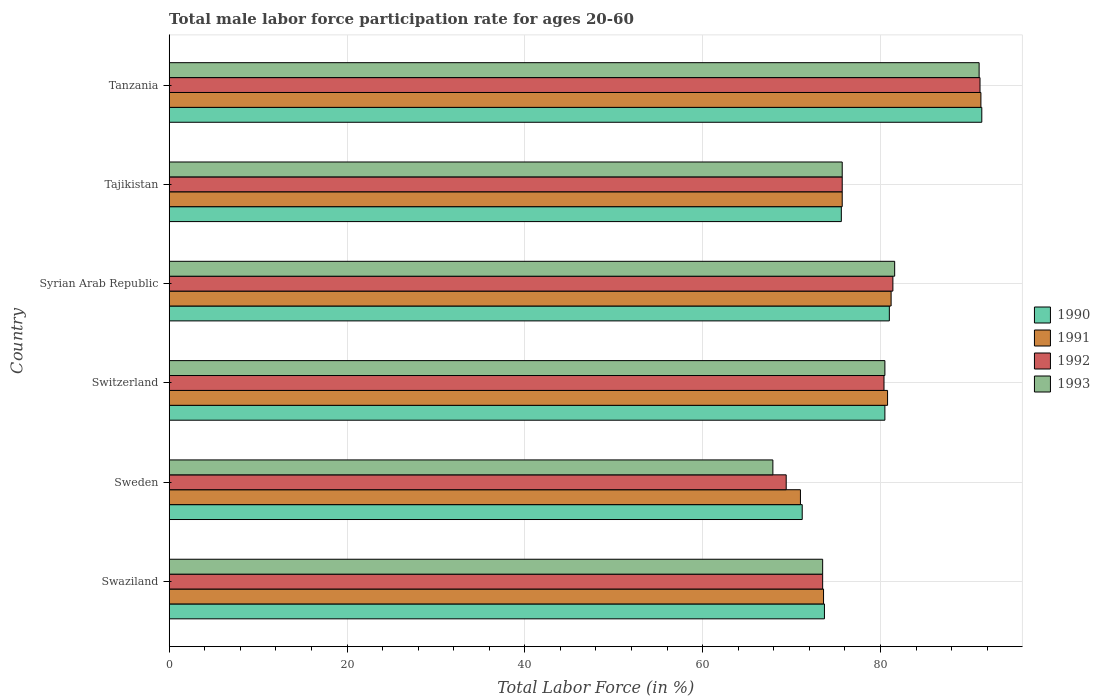How many different coloured bars are there?
Make the answer very short. 4. What is the label of the 3rd group of bars from the top?
Your answer should be compact. Syrian Arab Republic. In how many cases, is the number of bars for a given country not equal to the number of legend labels?
Give a very brief answer. 0. What is the male labor force participation rate in 1990 in Tanzania?
Keep it short and to the point. 91.4. Across all countries, what is the maximum male labor force participation rate in 1993?
Your answer should be compact. 91.1. Across all countries, what is the minimum male labor force participation rate in 1992?
Your answer should be compact. 69.4. In which country was the male labor force participation rate in 1993 maximum?
Your answer should be very brief. Tanzania. What is the total male labor force participation rate in 1991 in the graph?
Provide a succinct answer. 473.6. What is the difference between the male labor force participation rate in 1993 in Sweden and that in Switzerland?
Give a very brief answer. -12.6. What is the difference between the male labor force participation rate in 1993 in Syrian Arab Republic and the male labor force participation rate in 1990 in Sweden?
Ensure brevity in your answer.  10.4. What is the average male labor force participation rate in 1993 per country?
Offer a very short reply. 78.38. What is the difference between the male labor force participation rate in 1993 and male labor force participation rate in 1990 in Tajikistan?
Ensure brevity in your answer.  0.1. In how many countries, is the male labor force participation rate in 1992 greater than 12 %?
Your answer should be compact. 6. What is the ratio of the male labor force participation rate in 1991 in Switzerland to that in Syrian Arab Republic?
Offer a very short reply. 1. What is the difference between the highest and the second highest male labor force participation rate in 1993?
Your answer should be compact. 9.5. What is the difference between the highest and the lowest male labor force participation rate in 1991?
Provide a short and direct response. 20.3. Is the sum of the male labor force participation rate in 1993 in Swaziland and Tanzania greater than the maximum male labor force participation rate in 1990 across all countries?
Keep it short and to the point. Yes. What does the 1st bar from the top in Syrian Arab Republic represents?
Give a very brief answer. 1993. What does the 3rd bar from the bottom in Swaziland represents?
Provide a succinct answer. 1992. How many bars are there?
Make the answer very short. 24. Are all the bars in the graph horizontal?
Offer a very short reply. Yes. How many countries are there in the graph?
Ensure brevity in your answer.  6. Does the graph contain grids?
Provide a succinct answer. Yes. Where does the legend appear in the graph?
Make the answer very short. Center right. How many legend labels are there?
Your answer should be compact. 4. What is the title of the graph?
Make the answer very short. Total male labor force participation rate for ages 20-60. Does "1981" appear as one of the legend labels in the graph?
Offer a very short reply. No. What is the Total Labor Force (in %) of 1990 in Swaziland?
Make the answer very short. 73.7. What is the Total Labor Force (in %) of 1991 in Swaziland?
Give a very brief answer. 73.6. What is the Total Labor Force (in %) in 1992 in Swaziland?
Your response must be concise. 73.5. What is the Total Labor Force (in %) in 1993 in Swaziland?
Your answer should be very brief. 73.5. What is the Total Labor Force (in %) of 1990 in Sweden?
Give a very brief answer. 71.2. What is the Total Labor Force (in %) in 1991 in Sweden?
Your answer should be compact. 71. What is the Total Labor Force (in %) in 1992 in Sweden?
Provide a succinct answer. 69.4. What is the Total Labor Force (in %) in 1993 in Sweden?
Offer a very short reply. 67.9. What is the Total Labor Force (in %) of 1990 in Switzerland?
Keep it short and to the point. 80.5. What is the Total Labor Force (in %) in 1991 in Switzerland?
Provide a succinct answer. 80.8. What is the Total Labor Force (in %) in 1992 in Switzerland?
Your response must be concise. 80.4. What is the Total Labor Force (in %) of 1993 in Switzerland?
Give a very brief answer. 80.5. What is the Total Labor Force (in %) in 1990 in Syrian Arab Republic?
Your answer should be very brief. 81. What is the Total Labor Force (in %) of 1991 in Syrian Arab Republic?
Ensure brevity in your answer.  81.2. What is the Total Labor Force (in %) in 1992 in Syrian Arab Republic?
Provide a short and direct response. 81.4. What is the Total Labor Force (in %) of 1993 in Syrian Arab Republic?
Give a very brief answer. 81.6. What is the Total Labor Force (in %) in 1990 in Tajikistan?
Offer a very short reply. 75.6. What is the Total Labor Force (in %) of 1991 in Tajikistan?
Your response must be concise. 75.7. What is the Total Labor Force (in %) in 1992 in Tajikistan?
Provide a short and direct response. 75.7. What is the Total Labor Force (in %) of 1993 in Tajikistan?
Provide a short and direct response. 75.7. What is the Total Labor Force (in %) in 1990 in Tanzania?
Make the answer very short. 91.4. What is the Total Labor Force (in %) in 1991 in Tanzania?
Provide a succinct answer. 91.3. What is the Total Labor Force (in %) in 1992 in Tanzania?
Make the answer very short. 91.2. What is the Total Labor Force (in %) of 1993 in Tanzania?
Offer a terse response. 91.1. Across all countries, what is the maximum Total Labor Force (in %) in 1990?
Offer a terse response. 91.4. Across all countries, what is the maximum Total Labor Force (in %) of 1991?
Your answer should be very brief. 91.3. Across all countries, what is the maximum Total Labor Force (in %) of 1992?
Provide a short and direct response. 91.2. Across all countries, what is the maximum Total Labor Force (in %) of 1993?
Offer a very short reply. 91.1. Across all countries, what is the minimum Total Labor Force (in %) in 1990?
Keep it short and to the point. 71.2. Across all countries, what is the minimum Total Labor Force (in %) of 1991?
Your answer should be very brief. 71. Across all countries, what is the minimum Total Labor Force (in %) in 1992?
Your answer should be very brief. 69.4. Across all countries, what is the minimum Total Labor Force (in %) in 1993?
Make the answer very short. 67.9. What is the total Total Labor Force (in %) in 1990 in the graph?
Give a very brief answer. 473.4. What is the total Total Labor Force (in %) in 1991 in the graph?
Provide a short and direct response. 473.6. What is the total Total Labor Force (in %) of 1992 in the graph?
Keep it short and to the point. 471.6. What is the total Total Labor Force (in %) in 1993 in the graph?
Your response must be concise. 470.3. What is the difference between the Total Labor Force (in %) in 1992 in Swaziland and that in Sweden?
Offer a very short reply. 4.1. What is the difference between the Total Labor Force (in %) in 1993 in Swaziland and that in Sweden?
Your answer should be compact. 5.6. What is the difference between the Total Labor Force (in %) of 1991 in Swaziland and that in Switzerland?
Your answer should be compact. -7.2. What is the difference between the Total Labor Force (in %) in 1992 in Swaziland and that in Switzerland?
Your answer should be very brief. -6.9. What is the difference between the Total Labor Force (in %) in 1991 in Swaziland and that in Syrian Arab Republic?
Offer a very short reply. -7.6. What is the difference between the Total Labor Force (in %) in 1991 in Swaziland and that in Tajikistan?
Your answer should be very brief. -2.1. What is the difference between the Total Labor Force (in %) in 1990 in Swaziland and that in Tanzania?
Your answer should be very brief. -17.7. What is the difference between the Total Labor Force (in %) in 1991 in Swaziland and that in Tanzania?
Your response must be concise. -17.7. What is the difference between the Total Labor Force (in %) in 1992 in Swaziland and that in Tanzania?
Keep it short and to the point. -17.7. What is the difference between the Total Labor Force (in %) in 1993 in Swaziland and that in Tanzania?
Offer a very short reply. -17.6. What is the difference between the Total Labor Force (in %) in 1990 in Sweden and that in Switzerland?
Give a very brief answer. -9.3. What is the difference between the Total Labor Force (in %) in 1993 in Sweden and that in Switzerland?
Provide a short and direct response. -12.6. What is the difference between the Total Labor Force (in %) in 1991 in Sweden and that in Syrian Arab Republic?
Offer a very short reply. -10.2. What is the difference between the Total Labor Force (in %) in 1993 in Sweden and that in Syrian Arab Republic?
Give a very brief answer. -13.7. What is the difference between the Total Labor Force (in %) of 1991 in Sweden and that in Tajikistan?
Offer a terse response. -4.7. What is the difference between the Total Labor Force (in %) of 1990 in Sweden and that in Tanzania?
Keep it short and to the point. -20.2. What is the difference between the Total Labor Force (in %) of 1991 in Sweden and that in Tanzania?
Your answer should be compact. -20.3. What is the difference between the Total Labor Force (in %) of 1992 in Sweden and that in Tanzania?
Provide a short and direct response. -21.8. What is the difference between the Total Labor Force (in %) of 1993 in Sweden and that in Tanzania?
Keep it short and to the point. -23.2. What is the difference between the Total Labor Force (in %) of 1990 in Switzerland and that in Syrian Arab Republic?
Offer a very short reply. -0.5. What is the difference between the Total Labor Force (in %) in 1991 in Switzerland and that in Syrian Arab Republic?
Offer a very short reply. -0.4. What is the difference between the Total Labor Force (in %) of 1992 in Switzerland and that in Syrian Arab Republic?
Offer a terse response. -1. What is the difference between the Total Labor Force (in %) of 1993 in Switzerland and that in Syrian Arab Republic?
Give a very brief answer. -1.1. What is the difference between the Total Labor Force (in %) of 1991 in Switzerland and that in Tajikistan?
Provide a succinct answer. 5.1. What is the difference between the Total Labor Force (in %) in 1993 in Switzerland and that in Tanzania?
Make the answer very short. -10.6. What is the difference between the Total Labor Force (in %) in 1990 in Syrian Arab Republic and that in Tajikistan?
Provide a short and direct response. 5.4. What is the difference between the Total Labor Force (in %) in 1992 in Syrian Arab Republic and that in Tajikistan?
Provide a short and direct response. 5.7. What is the difference between the Total Labor Force (in %) in 1990 in Syrian Arab Republic and that in Tanzania?
Your answer should be compact. -10.4. What is the difference between the Total Labor Force (in %) of 1992 in Syrian Arab Republic and that in Tanzania?
Make the answer very short. -9.8. What is the difference between the Total Labor Force (in %) in 1990 in Tajikistan and that in Tanzania?
Ensure brevity in your answer.  -15.8. What is the difference between the Total Labor Force (in %) in 1991 in Tajikistan and that in Tanzania?
Provide a short and direct response. -15.6. What is the difference between the Total Labor Force (in %) in 1992 in Tajikistan and that in Tanzania?
Ensure brevity in your answer.  -15.5. What is the difference between the Total Labor Force (in %) of 1993 in Tajikistan and that in Tanzania?
Your answer should be compact. -15.4. What is the difference between the Total Labor Force (in %) of 1990 in Swaziland and the Total Labor Force (in %) of 1992 in Sweden?
Your answer should be very brief. 4.3. What is the difference between the Total Labor Force (in %) in 1990 in Swaziland and the Total Labor Force (in %) in 1993 in Sweden?
Give a very brief answer. 5.8. What is the difference between the Total Labor Force (in %) of 1991 in Swaziland and the Total Labor Force (in %) of 1992 in Sweden?
Make the answer very short. 4.2. What is the difference between the Total Labor Force (in %) of 1992 in Swaziland and the Total Labor Force (in %) of 1993 in Sweden?
Make the answer very short. 5.6. What is the difference between the Total Labor Force (in %) of 1990 in Swaziland and the Total Labor Force (in %) of 1991 in Switzerland?
Provide a succinct answer. -7.1. What is the difference between the Total Labor Force (in %) in 1991 in Swaziland and the Total Labor Force (in %) in 1993 in Switzerland?
Provide a short and direct response. -6.9. What is the difference between the Total Labor Force (in %) in 1990 in Swaziland and the Total Labor Force (in %) in 1992 in Syrian Arab Republic?
Your response must be concise. -7.7. What is the difference between the Total Labor Force (in %) in 1990 in Swaziland and the Total Labor Force (in %) in 1993 in Syrian Arab Republic?
Provide a succinct answer. -7.9. What is the difference between the Total Labor Force (in %) in 1992 in Swaziland and the Total Labor Force (in %) in 1993 in Syrian Arab Republic?
Keep it short and to the point. -8.1. What is the difference between the Total Labor Force (in %) in 1991 in Swaziland and the Total Labor Force (in %) in 1993 in Tajikistan?
Ensure brevity in your answer.  -2.1. What is the difference between the Total Labor Force (in %) of 1992 in Swaziland and the Total Labor Force (in %) of 1993 in Tajikistan?
Give a very brief answer. -2.2. What is the difference between the Total Labor Force (in %) in 1990 in Swaziland and the Total Labor Force (in %) in 1991 in Tanzania?
Provide a short and direct response. -17.6. What is the difference between the Total Labor Force (in %) of 1990 in Swaziland and the Total Labor Force (in %) of 1992 in Tanzania?
Make the answer very short. -17.5. What is the difference between the Total Labor Force (in %) of 1990 in Swaziland and the Total Labor Force (in %) of 1993 in Tanzania?
Make the answer very short. -17.4. What is the difference between the Total Labor Force (in %) of 1991 in Swaziland and the Total Labor Force (in %) of 1992 in Tanzania?
Keep it short and to the point. -17.6. What is the difference between the Total Labor Force (in %) of 1991 in Swaziland and the Total Labor Force (in %) of 1993 in Tanzania?
Provide a short and direct response. -17.5. What is the difference between the Total Labor Force (in %) of 1992 in Swaziland and the Total Labor Force (in %) of 1993 in Tanzania?
Provide a succinct answer. -17.6. What is the difference between the Total Labor Force (in %) in 1991 in Sweden and the Total Labor Force (in %) in 1993 in Switzerland?
Your answer should be very brief. -9.5. What is the difference between the Total Labor Force (in %) of 1992 in Sweden and the Total Labor Force (in %) of 1993 in Switzerland?
Your answer should be very brief. -11.1. What is the difference between the Total Labor Force (in %) of 1990 in Sweden and the Total Labor Force (in %) of 1991 in Syrian Arab Republic?
Ensure brevity in your answer.  -10. What is the difference between the Total Labor Force (in %) of 1990 in Sweden and the Total Labor Force (in %) of 1992 in Syrian Arab Republic?
Your answer should be very brief. -10.2. What is the difference between the Total Labor Force (in %) in 1990 in Sweden and the Total Labor Force (in %) in 1993 in Syrian Arab Republic?
Provide a short and direct response. -10.4. What is the difference between the Total Labor Force (in %) of 1991 in Sweden and the Total Labor Force (in %) of 1992 in Syrian Arab Republic?
Make the answer very short. -10.4. What is the difference between the Total Labor Force (in %) of 1991 in Sweden and the Total Labor Force (in %) of 1993 in Syrian Arab Republic?
Make the answer very short. -10.6. What is the difference between the Total Labor Force (in %) in 1990 in Sweden and the Total Labor Force (in %) in 1992 in Tajikistan?
Offer a terse response. -4.5. What is the difference between the Total Labor Force (in %) in 1990 in Sweden and the Total Labor Force (in %) in 1993 in Tajikistan?
Your answer should be very brief. -4.5. What is the difference between the Total Labor Force (in %) of 1991 in Sweden and the Total Labor Force (in %) of 1992 in Tajikistan?
Make the answer very short. -4.7. What is the difference between the Total Labor Force (in %) of 1991 in Sweden and the Total Labor Force (in %) of 1993 in Tajikistan?
Offer a terse response. -4.7. What is the difference between the Total Labor Force (in %) of 1990 in Sweden and the Total Labor Force (in %) of 1991 in Tanzania?
Provide a short and direct response. -20.1. What is the difference between the Total Labor Force (in %) of 1990 in Sweden and the Total Labor Force (in %) of 1993 in Tanzania?
Provide a short and direct response. -19.9. What is the difference between the Total Labor Force (in %) in 1991 in Sweden and the Total Labor Force (in %) in 1992 in Tanzania?
Your answer should be very brief. -20.2. What is the difference between the Total Labor Force (in %) of 1991 in Sweden and the Total Labor Force (in %) of 1993 in Tanzania?
Ensure brevity in your answer.  -20.1. What is the difference between the Total Labor Force (in %) in 1992 in Sweden and the Total Labor Force (in %) in 1993 in Tanzania?
Your response must be concise. -21.7. What is the difference between the Total Labor Force (in %) of 1990 in Switzerland and the Total Labor Force (in %) of 1991 in Syrian Arab Republic?
Provide a succinct answer. -0.7. What is the difference between the Total Labor Force (in %) of 1991 in Switzerland and the Total Labor Force (in %) of 1992 in Syrian Arab Republic?
Provide a succinct answer. -0.6. What is the difference between the Total Labor Force (in %) in 1991 in Switzerland and the Total Labor Force (in %) in 1993 in Syrian Arab Republic?
Ensure brevity in your answer.  -0.8. What is the difference between the Total Labor Force (in %) in 1991 in Switzerland and the Total Labor Force (in %) in 1992 in Tajikistan?
Offer a very short reply. 5.1. What is the difference between the Total Labor Force (in %) in 1990 in Switzerland and the Total Labor Force (in %) in 1991 in Tanzania?
Your answer should be very brief. -10.8. What is the difference between the Total Labor Force (in %) in 1990 in Switzerland and the Total Labor Force (in %) in 1992 in Tanzania?
Your answer should be very brief. -10.7. What is the difference between the Total Labor Force (in %) in 1990 in Switzerland and the Total Labor Force (in %) in 1993 in Tanzania?
Your answer should be very brief. -10.6. What is the difference between the Total Labor Force (in %) of 1991 in Switzerland and the Total Labor Force (in %) of 1993 in Tanzania?
Offer a terse response. -10.3. What is the difference between the Total Labor Force (in %) in 1990 in Syrian Arab Republic and the Total Labor Force (in %) in 1992 in Tajikistan?
Offer a very short reply. 5.3. What is the difference between the Total Labor Force (in %) of 1990 in Syrian Arab Republic and the Total Labor Force (in %) of 1993 in Tajikistan?
Your response must be concise. 5.3. What is the difference between the Total Labor Force (in %) of 1992 in Syrian Arab Republic and the Total Labor Force (in %) of 1993 in Tajikistan?
Offer a terse response. 5.7. What is the difference between the Total Labor Force (in %) of 1990 in Syrian Arab Republic and the Total Labor Force (in %) of 1991 in Tanzania?
Your response must be concise. -10.3. What is the difference between the Total Labor Force (in %) of 1990 in Syrian Arab Republic and the Total Labor Force (in %) of 1992 in Tanzania?
Provide a succinct answer. -10.2. What is the difference between the Total Labor Force (in %) of 1990 in Syrian Arab Republic and the Total Labor Force (in %) of 1993 in Tanzania?
Keep it short and to the point. -10.1. What is the difference between the Total Labor Force (in %) in 1990 in Tajikistan and the Total Labor Force (in %) in 1991 in Tanzania?
Provide a succinct answer. -15.7. What is the difference between the Total Labor Force (in %) in 1990 in Tajikistan and the Total Labor Force (in %) in 1992 in Tanzania?
Provide a short and direct response. -15.6. What is the difference between the Total Labor Force (in %) in 1990 in Tajikistan and the Total Labor Force (in %) in 1993 in Tanzania?
Keep it short and to the point. -15.5. What is the difference between the Total Labor Force (in %) in 1991 in Tajikistan and the Total Labor Force (in %) in 1992 in Tanzania?
Keep it short and to the point. -15.5. What is the difference between the Total Labor Force (in %) of 1991 in Tajikistan and the Total Labor Force (in %) of 1993 in Tanzania?
Your response must be concise. -15.4. What is the difference between the Total Labor Force (in %) in 1992 in Tajikistan and the Total Labor Force (in %) in 1993 in Tanzania?
Give a very brief answer. -15.4. What is the average Total Labor Force (in %) in 1990 per country?
Provide a short and direct response. 78.9. What is the average Total Labor Force (in %) in 1991 per country?
Offer a very short reply. 78.93. What is the average Total Labor Force (in %) of 1992 per country?
Offer a terse response. 78.6. What is the average Total Labor Force (in %) of 1993 per country?
Provide a succinct answer. 78.38. What is the difference between the Total Labor Force (in %) of 1990 and Total Labor Force (in %) of 1992 in Swaziland?
Offer a terse response. 0.2. What is the difference between the Total Labor Force (in %) in 1991 and Total Labor Force (in %) in 1992 in Swaziland?
Give a very brief answer. 0.1. What is the difference between the Total Labor Force (in %) in 1990 and Total Labor Force (in %) in 1991 in Sweden?
Provide a succinct answer. 0.2. What is the difference between the Total Labor Force (in %) of 1990 and Total Labor Force (in %) of 1992 in Sweden?
Your response must be concise. 1.8. What is the difference between the Total Labor Force (in %) of 1991 and Total Labor Force (in %) of 1993 in Sweden?
Give a very brief answer. 3.1. What is the difference between the Total Labor Force (in %) of 1990 and Total Labor Force (in %) of 1992 in Switzerland?
Your answer should be compact. 0.1. What is the difference between the Total Labor Force (in %) of 1991 and Total Labor Force (in %) of 1993 in Switzerland?
Your answer should be compact. 0.3. What is the difference between the Total Labor Force (in %) of 1992 and Total Labor Force (in %) of 1993 in Switzerland?
Ensure brevity in your answer.  -0.1. What is the difference between the Total Labor Force (in %) of 1990 and Total Labor Force (in %) of 1991 in Syrian Arab Republic?
Provide a succinct answer. -0.2. What is the difference between the Total Labor Force (in %) of 1990 and Total Labor Force (in %) of 1992 in Syrian Arab Republic?
Offer a terse response. -0.4. What is the difference between the Total Labor Force (in %) in 1990 and Total Labor Force (in %) in 1991 in Tajikistan?
Give a very brief answer. -0.1. What is the difference between the Total Labor Force (in %) in 1990 and Total Labor Force (in %) in 1993 in Tajikistan?
Make the answer very short. -0.1. What is the difference between the Total Labor Force (in %) in 1991 and Total Labor Force (in %) in 1993 in Tajikistan?
Offer a very short reply. 0. What is the difference between the Total Labor Force (in %) of 1990 and Total Labor Force (in %) of 1992 in Tanzania?
Give a very brief answer. 0.2. What is the ratio of the Total Labor Force (in %) of 1990 in Swaziland to that in Sweden?
Offer a very short reply. 1.04. What is the ratio of the Total Labor Force (in %) of 1991 in Swaziland to that in Sweden?
Your response must be concise. 1.04. What is the ratio of the Total Labor Force (in %) of 1992 in Swaziland to that in Sweden?
Offer a terse response. 1.06. What is the ratio of the Total Labor Force (in %) in 1993 in Swaziland to that in Sweden?
Provide a succinct answer. 1.08. What is the ratio of the Total Labor Force (in %) of 1990 in Swaziland to that in Switzerland?
Your answer should be very brief. 0.92. What is the ratio of the Total Labor Force (in %) of 1991 in Swaziland to that in Switzerland?
Keep it short and to the point. 0.91. What is the ratio of the Total Labor Force (in %) of 1992 in Swaziland to that in Switzerland?
Give a very brief answer. 0.91. What is the ratio of the Total Labor Force (in %) of 1993 in Swaziland to that in Switzerland?
Offer a very short reply. 0.91. What is the ratio of the Total Labor Force (in %) in 1990 in Swaziland to that in Syrian Arab Republic?
Make the answer very short. 0.91. What is the ratio of the Total Labor Force (in %) of 1991 in Swaziland to that in Syrian Arab Republic?
Ensure brevity in your answer.  0.91. What is the ratio of the Total Labor Force (in %) in 1992 in Swaziland to that in Syrian Arab Republic?
Make the answer very short. 0.9. What is the ratio of the Total Labor Force (in %) in 1993 in Swaziland to that in Syrian Arab Republic?
Ensure brevity in your answer.  0.9. What is the ratio of the Total Labor Force (in %) of 1990 in Swaziland to that in Tajikistan?
Make the answer very short. 0.97. What is the ratio of the Total Labor Force (in %) of 1991 in Swaziland to that in Tajikistan?
Offer a terse response. 0.97. What is the ratio of the Total Labor Force (in %) in 1992 in Swaziland to that in Tajikistan?
Ensure brevity in your answer.  0.97. What is the ratio of the Total Labor Force (in %) of 1993 in Swaziland to that in Tajikistan?
Ensure brevity in your answer.  0.97. What is the ratio of the Total Labor Force (in %) in 1990 in Swaziland to that in Tanzania?
Provide a short and direct response. 0.81. What is the ratio of the Total Labor Force (in %) of 1991 in Swaziland to that in Tanzania?
Provide a short and direct response. 0.81. What is the ratio of the Total Labor Force (in %) in 1992 in Swaziland to that in Tanzania?
Offer a very short reply. 0.81. What is the ratio of the Total Labor Force (in %) of 1993 in Swaziland to that in Tanzania?
Provide a short and direct response. 0.81. What is the ratio of the Total Labor Force (in %) of 1990 in Sweden to that in Switzerland?
Give a very brief answer. 0.88. What is the ratio of the Total Labor Force (in %) in 1991 in Sweden to that in Switzerland?
Ensure brevity in your answer.  0.88. What is the ratio of the Total Labor Force (in %) of 1992 in Sweden to that in Switzerland?
Ensure brevity in your answer.  0.86. What is the ratio of the Total Labor Force (in %) in 1993 in Sweden to that in Switzerland?
Your answer should be compact. 0.84. What is the ratio of the Total Labor Force (in %) of 1990 in Sweden to that in Syrian Arab Republic?
Provide a succinct answer. 0.88. What is the ratio of the Total Labor Force (in %) in 1991 in Sweden to that in Syrian Arab Republic?
Provide a succinct answer. 0.87. What is the ratio of the Total Labor Force (in %) in 1992 in Sweden to that in Syrian Arab Republic?
Offer a terse response. 0.85. What is the ratio of the Total Labor Force (in %) in 1993 in Sweden to that in Syrian Arab Republic?
Offer a terse response. 0.83. What is the ratio of the Total Labor Force (in %) in 1990 in Sweden to that in Tajikistan?
Provide a succinct answer. 0.94. What is the ratio of the Total Labor Force (in %) of 1991 in Sweden to that in Tajikistan?
Provide a succinct answer. 0.94. What is the ratio of the Total Labor Force (in %) of 1992 in Sweden to that in Tajikistan?
Offer a terse response. 0.92. What is the ratio of the Total Labor Force (in %) in 1993 in Sweden to that in Tajikistan?
Your answer should be compact. 0.9. What is the ratio of the Total Labor Force (in %) in 1990 in Sweden to that in Tanzania?
Offer a very short reply. 0.78. What is the ratio of the Total Labor Force (in %) in 1991 in Sweden to that in Tanzania?
Your answer should be very brief. 0.78. What is the ratio of the Total Labor Force (in %) of 1992 in Sweden to that in Tanzania?
Provide a succinct answer. 0.76. What is the ratio of the Total Labor Force (in %) of 1993 in Sweden to that in Tanzania?
Your answer should be compact. 0.75. What is the ratio of the Total Labor Force (in %) of 1991 in Switzerland to that in Syrian Arab Republic?
Keep it short and to the point. 1. What is the ratio of the Total Labor Force (in %) in 1992 in Switzerland to that in Syrian Arab Republic?
Provide a succinct answer. 0.99. What is the ratio of the Total Labor Force (in %) of 1993 in Switzerland to that in Syrian Arab Republic?
Provide a succinct answer. 0.99. What is the ratio of the Total Labor Force (in %) in 1990 in Switzerland to that in Tajikistan?
Offer a very short reply. 1.06. What is the ratio of the Total Labor Force (in %) of 1991 in Switzerland to that in Tajikistan?
Your answer should be compact. 1.07. What is the ratio of the Total Labor Force (in %) in 1992 in Switzerland to that in Tajikistan?
Your answer should be very brief. 1.06. What is the ratio of the Total Labor Force (in %) in 1993 in Switzerland to that in Tajikistan?
Ensure brevity in your answer.  1.06. What is the ratio of the Total Labor Force (in %) in 1990 in Switzerland to that in Tanzania?
Offer a terse response. 0.88. What is the ratio of the Total Labor Force (in %) in 1991 in Switzerland to that in Tanzania?
Your answer should be very brief. 0.89. What is the ratio of the Total Labor Force (in %) in 1992 in Switzerland to that in Tanzania?
Keep it short and to the point. 0.88. What is the ratio of the Total Labor Force (in %) in 1993 in Switzerland to that in Tanzania?
Your answer should be compact. 0.88. What is the ratio of the Total Labor Force (in %) of 1990 in Syrian Arab Republic to that in Tajikistan?
Offer a terse response. 1.07. What is the ratio of the Total Labor Force (in %) in 1991 in Syrian Arab Republic to that in Tajikistan?
Offer a terse response. 1.07. What is the ratio of the Total Labor Force (in %) in 1992 in Syrian Arab Republic to that in Tajikistan?
Ensure brevity in your answer.  1.08. What is the ratio of the Total Labor Force (in %) in 1993 in Syrian Arab Republic to that in Tajikistan?
Offer a very short reply. 1.08. What is the ratio of the Total Labor Force (in %) in 1990 in Syrian Arab Republic to that in Tanzania?
Offer a terse response. 0.89. What is the ratio of the Total Labor Force (in %) in 1991 in Syrian Arab Republic to that in Tanzania?
Make the answer very short. 0.89. What is the ratio of the Total Labor Force (in %) of 1992 in Syrian Arab Republic to that in Tanzania?
Make the answer very short. 0.89. What is the ratio of the Total Labor Force (in %) in 1993 in Syrian Arab Republic to that in Tanzania?
Make the answer very short. 0.9. What is the ratio of the Total Labor Force (in %) of 1990 in Tajikistan to that in Tanzania?
Provide a short and direct response. 0.83. What is the ratio of the Total Labor Force (in %) of 1991 in Tajikistan to that in Tanzania?
Ensure brevity in your answer.  0.83. What is the ratio of the Total Labor Force (in %) in 1992 in Tajikistan to that in Tanzania?
Give a very brief answer. 0.83. What is the ratio of the Total Labor Force (in %) of 1993 in Tajikistan to that in Tanzania?
Make the answer very short. 0.83. What is the difference between the highest and the second highest Total Labor Force (in %) in 1991?
Offer a terse response. 10.1. What is the difference between the highest and the second highest Total Labor Force (in %) in 1992?
Offer a very short reply. 9.8. What is the difference between the highest and the lowest Total Labor Force (in %) in 1990?
Provide a succinct answer. 20.2. What is the difference between the highest and the lowest Total Labor Force (in %) in 1991?
Your answer should be compact. 20.3. What is the difference between the highest and the lowest Total Labor Force (in %) of 1992?
Make the answer very short. 21.8. What is the difference between the highest and the lowest Total Labor Force (in %) in 1993?
Give a very brief answer. 23.2. 